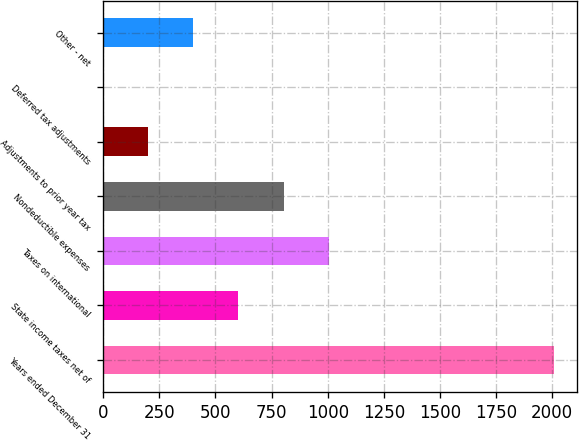<chart> <loc_0><loc_0><loc_500><loc_500><bar_chart><fcel>Years ended December 31<fcel>State income taxes net of<fcel>Taxes on international<fcel>Nondeductible expenses<fcel>Adjustments to prior year tax<fcel>Deferred tax adjustments<fcel>Other - net<nl><fcel>2008<fcel>602.54<fcel>1004.1<fcel>803.32<fcel>200.98<fcel>0.2<fcel>401.76<nl></chart> 